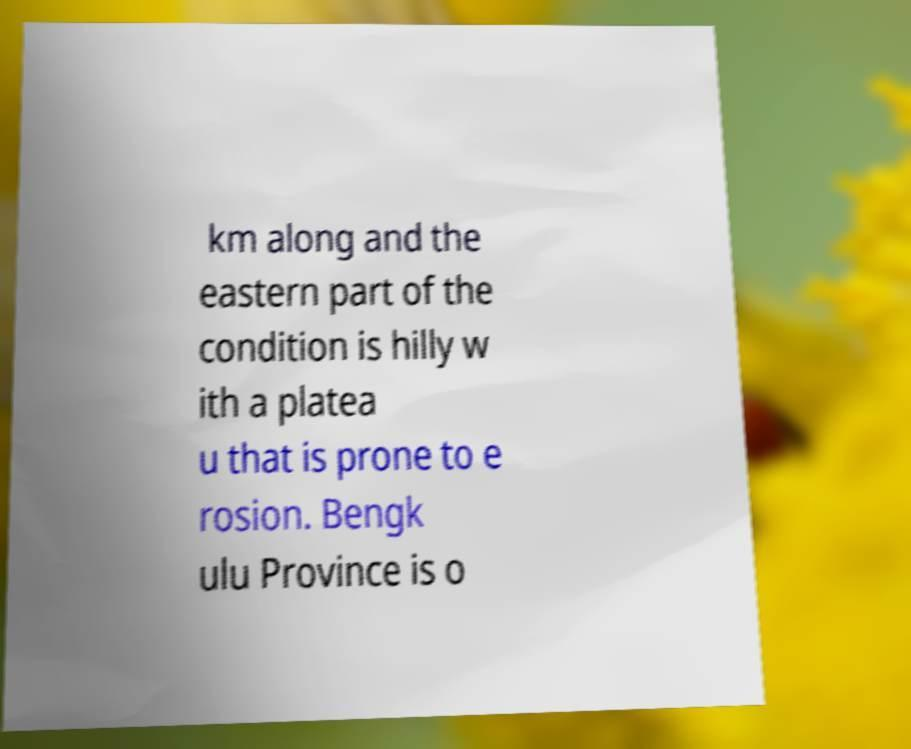Please identify and transcribe the text found in this image. km along and the eastern part of the condition is hilly w ith a platea u that is prone to e rosion. Bengk ulu Province is o 